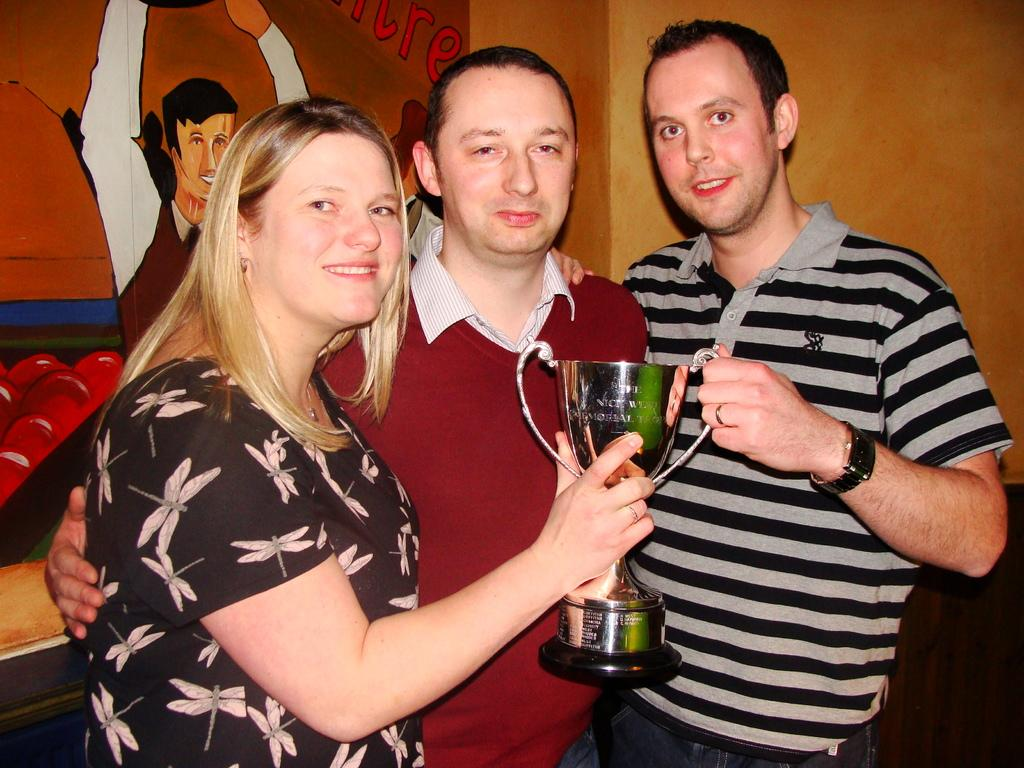How many people are in the image? There are three people standing in the center of the image. What are the people holding in the image? The people are holding a trophy. Can you describe anything on the wall in the background of the image? There is a board placed on the wall in the background of the image. What type of button is being used to cook in the image? There is no button or cooking activity present in the image. What type of business is being conducted in the image? The image does not depict any business activity; it shows three people holding a trophy. 